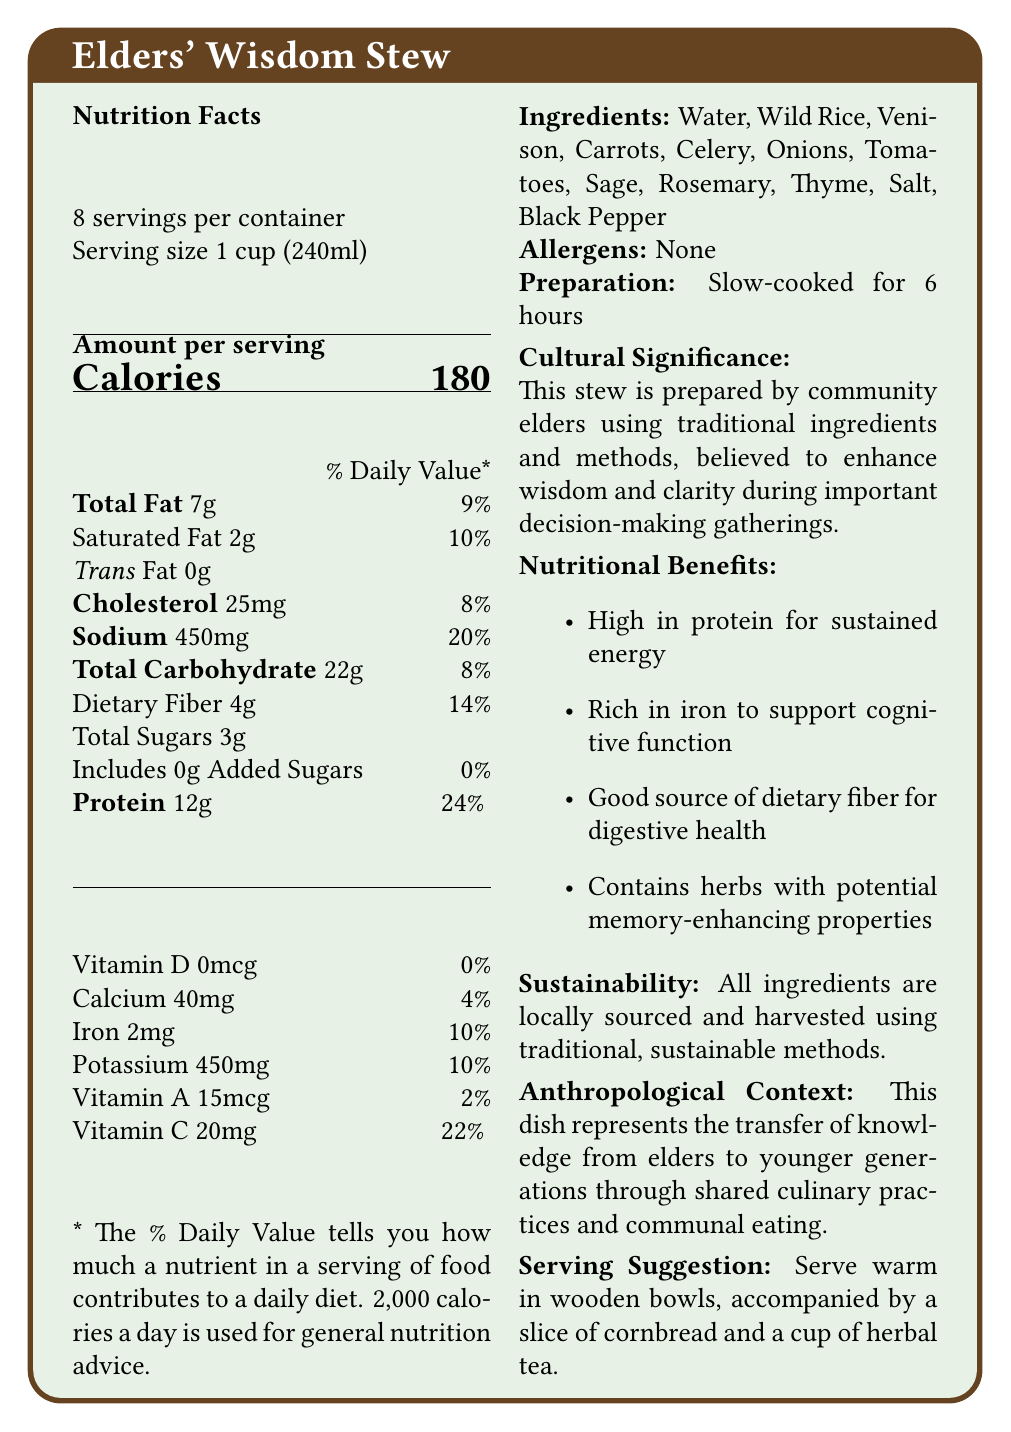What is the serving size of Elders' Wisdom Stew? The serving size is clearly stated as 1 cup (240ml) in the document.
Answer: 1 cup (240ml) How many servings are there per container of the stew? The document mentions that there are 8 servings per container.
Answer: 8 How much protein is in one serving of the stew? The "Amount per serving" section lists 12g of protein.
Answer: 12g What is the total carbohydrate content per serving? The "Total Carbohydrate" content per serving is listed as 22g.
Answer: 22g Which ingredient in the stew might support cognitive function due to its iron content? The nutritional benefits mention iron, and venison is a meat known for being high in iron.
Answer: Venison How long is the stew slow-cooked for? The preparation method specifies that the stew is slow-cooked for 6 hours.
Answer: 6 hours What is the cultural significance of Elders' Wisdom Stew? The document states that the stew is believed to enhance wisdom and clarity during important decision-making gatherings.
Answer: Enhances wisdom and clarity during important decision-making gatherings Which of the following nutrients is highest in percentage based on the % Daily Value per serving? A. Sodium B. Vitamin C C. Iron Sodium is at 20%, Vitamin C at 22%, and Iron at 10%.
Answer: A. Sodium Which ingredient is not included in Elders' Wisdom Stew? A. Garlic B. Wild Rice C. Sage D. Tomatoes The ingredients list includes wild rice, sage, and tomatoes, but not garlic.
Answer: A. Garlic Is the Elders' Wisdom Stew high in added sugars? The document states that the stew contains 0g of added sugars.
Answer: No Summarize the main idea of the document. The document provides information on the nutritional values, ingredients, cultural significance, and sustainability of Elders' Wisdom Stew, emphasizing its role in community traditions and decision-making processes.
Answer: The Elders' Wisdom Stew is a traditional ceremonial dish prepared by community elders, believed to enhance wisdom and clarity during important decision-making gatherings. It is high in protein and rich in nutrients like iron, dietary fiber, and herbs with memory-enhancing properties. The stew uses locally sourced and sustainable ingredients. What are the potential memory-enhancing ingredients in the stew? The nutritional benefits section mentions herbs with potential memory-enhancing properties, specifically referring to sage, rosemary, and thyme.
Answer: Sage, Rosemary, Thyme Does the document mention any potential allergens in the stew? The document explicitly states that there are no allergens.
Answer: No From which sources are the ingredients of Elders' Wisdom Stew obtained? The sustainability note in the document indicates that all ingredients are locally sourced and harvested using traditional methods.
Answer: Locally sourced and harvested using traditional, sustainable methods What is the vitamin A content per serving of the stew? The nutrition facts section lists the vitamin A content as 15mcg per serving.
Answer: 15mcg Is it mentioned how Elders' Wisdom Stew is served? The serving suggestion mentions serving the stew warm in wooden bowls, accompanied by a slice of cornbread and a cup of herbal tea.
Answer: Yes What percentage of the daily value of calcium does one serving provide? The nutrition facts section indicates that one serving provides 4% of the daily value of calcium.
Answer: 4% How many calories does one serving of the stew have? The document lists the calorie content per serving as 180.
Answer: 180 Can you determine the exact amount of each herb in the stew from the document? The document lists the herbs as ingredients but does not provide their exact amounts.
Answer: Cannot be determined 